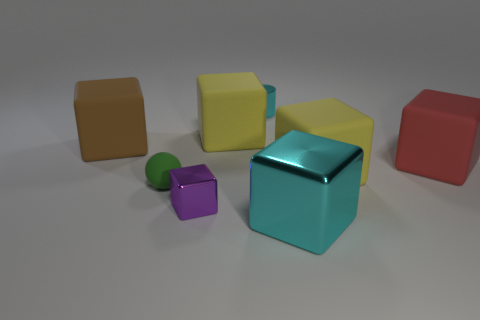Subtract all red blocks. How many blocks are left? 5 Subtract all metallic blocks. How many blocks are left? 4 Subtract 1 cubes. How many cubes are left? 5 Subtract all blue blocks. Subtract all yellow balls. How many blocks are left? 6 Add 2 tiny cyan matte things. How many objects exist? 10 Subtract all blocks. How many objects are left? 2 Add 3 big yellow things. How many big yellow things exist? 5 Subtract 1 brown blocks. How many objects are left? 7 Subtract all big brown blocks. Subtract all large purple cubes. How many objects are left? 7 Add 2 small spheres. How many small spheres are left? 3 